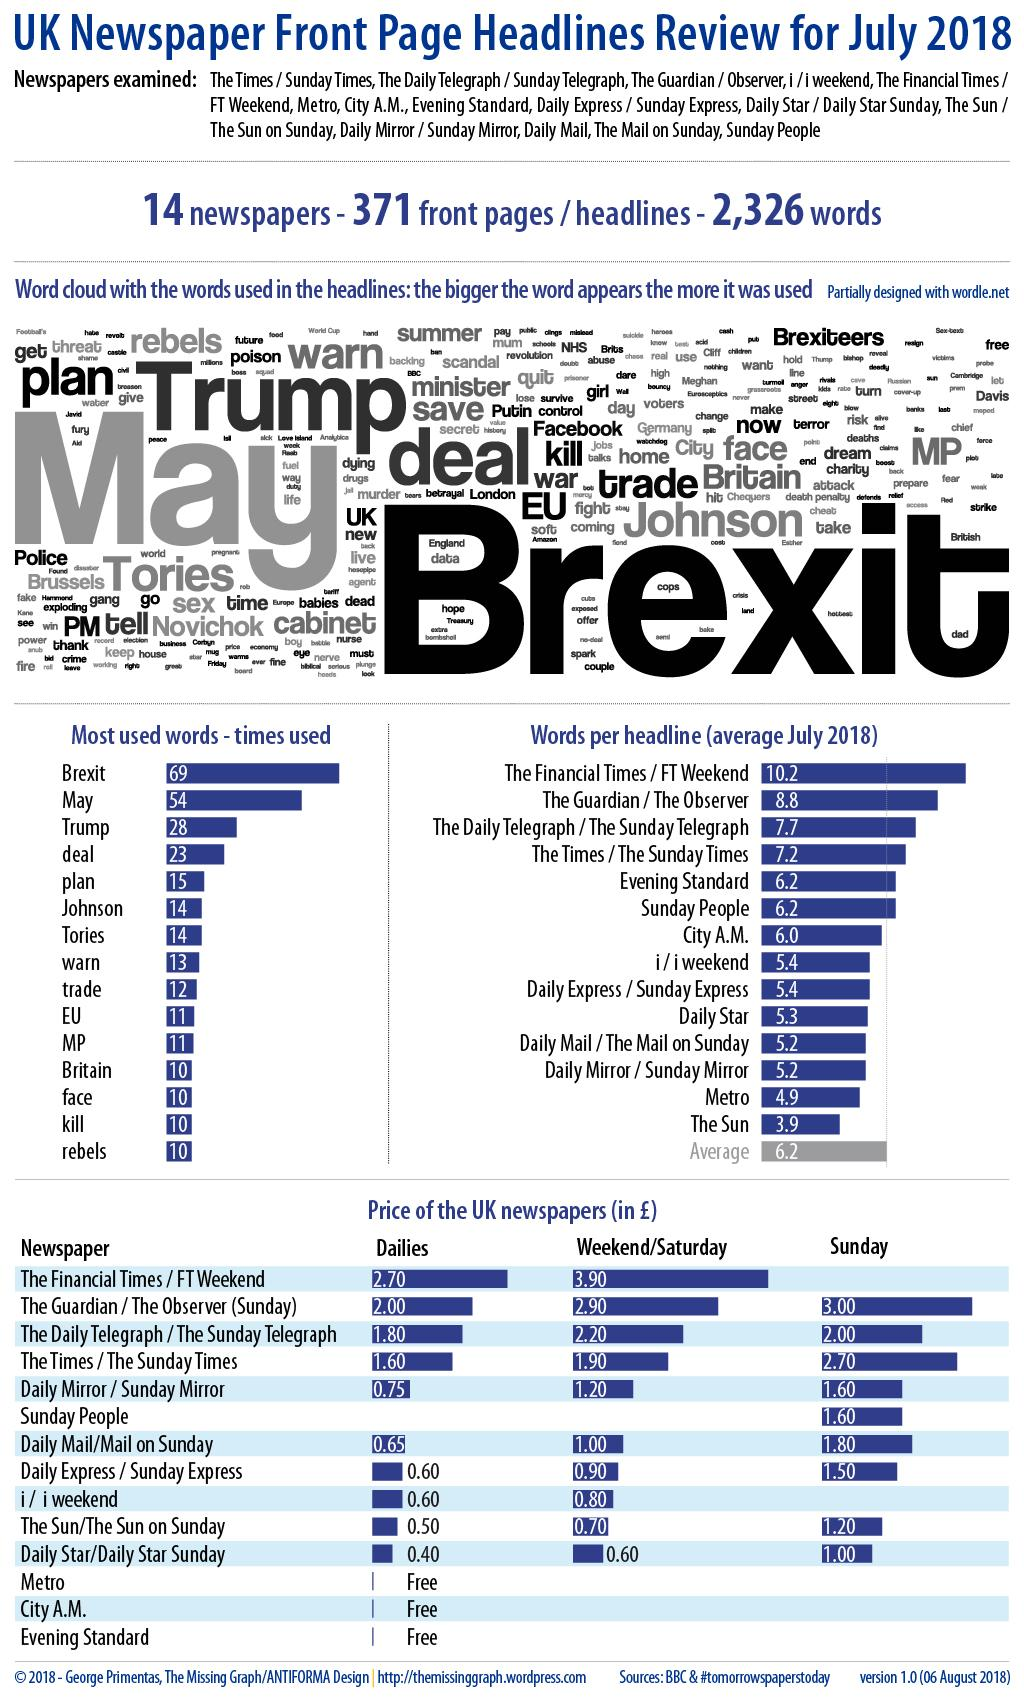Highlight a few significant elements in this photo. In the list, there are 4 words that have been used 10 times. There are 2 words in the list that are used more than 50 times. There are 15 words in the most commonly used words list. The word 'Trump' is used twice as much as Johnson. Which is the second most commonly used word? May... 